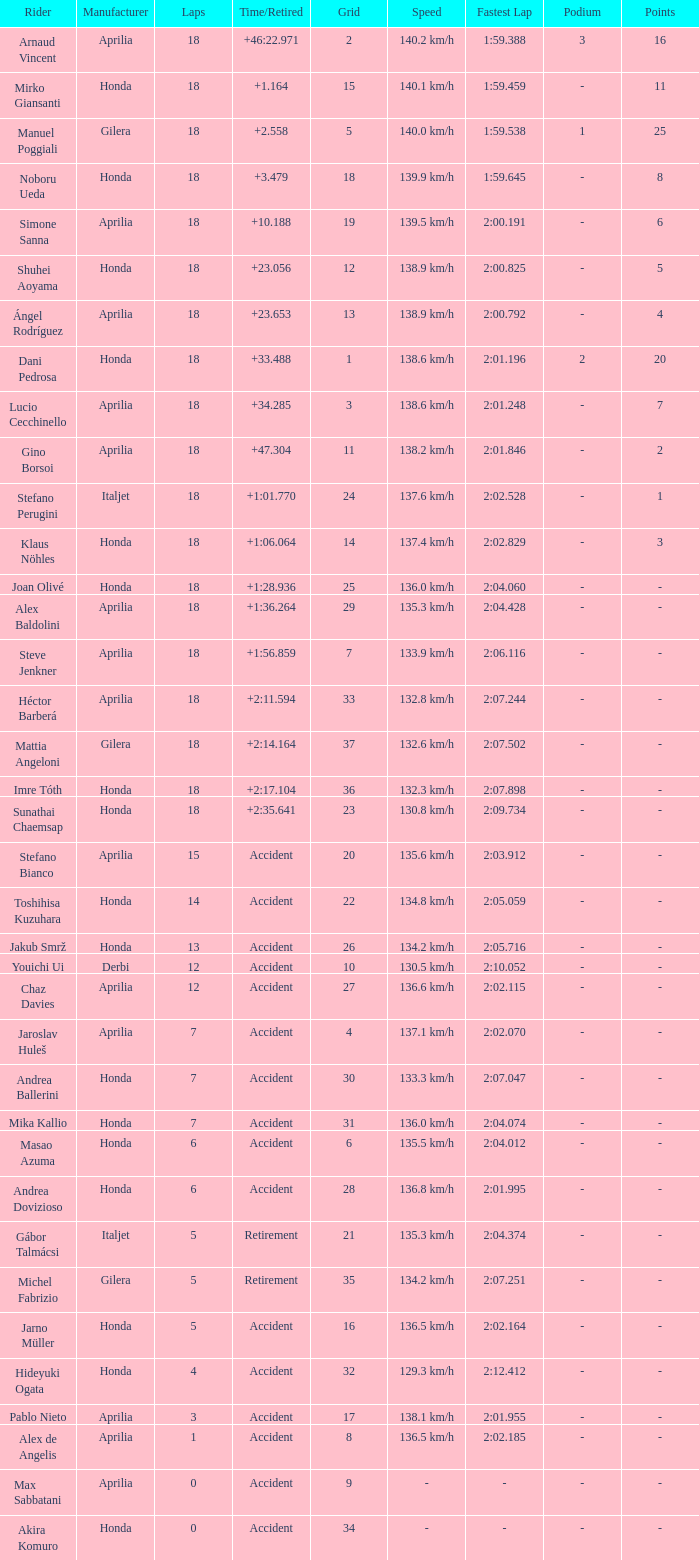What is the average number of laps with an accident time/retired, aprilia manufacturer and a grid of 27? 12.0. 